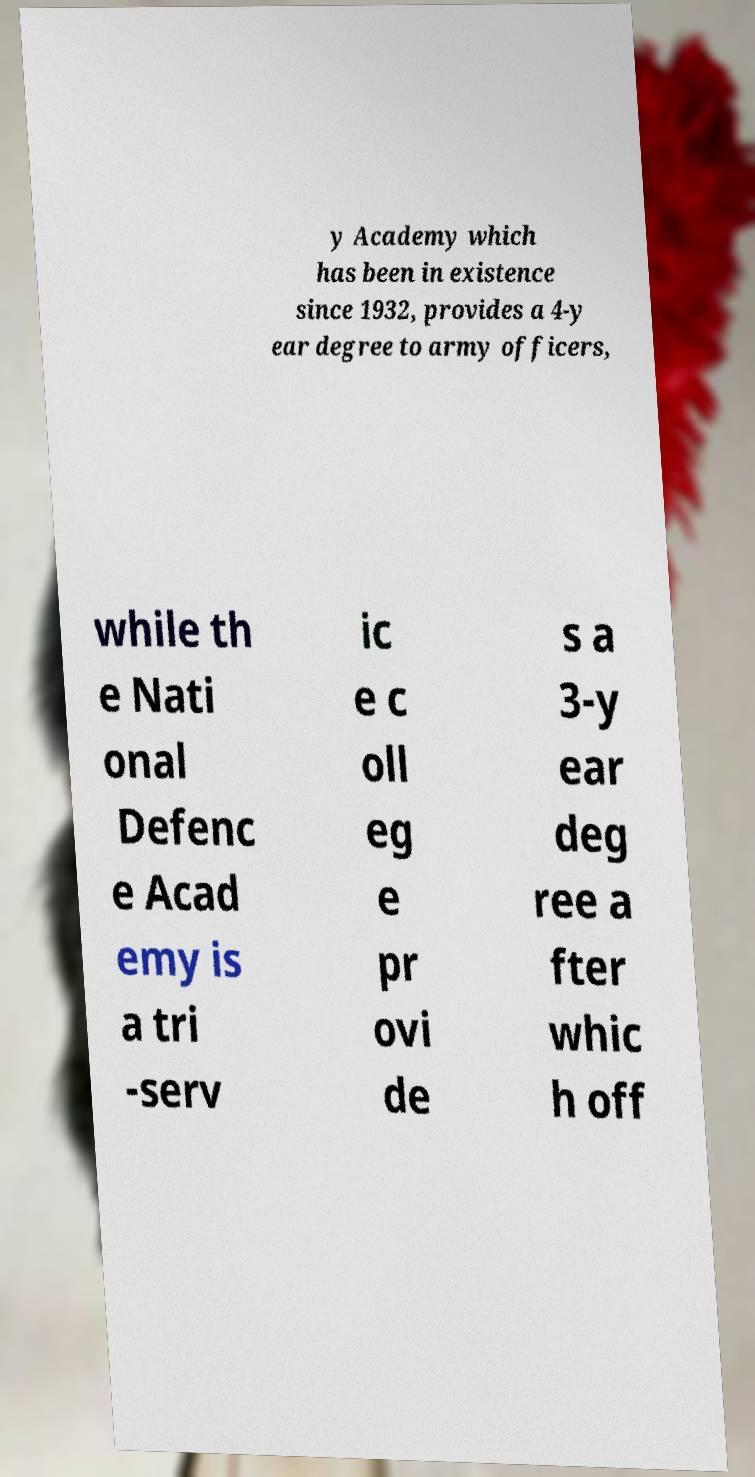I need the written content from this picture converted into text. Can you do that? y Academy which has been in existence since 1932, provides a 4-y ear degree to army officers, while th e Nati onal Defenc e Acad emy is a tri -serv ic e c oll eg e pr ovi de s a 3-y ear deg ree a fter whic h off 